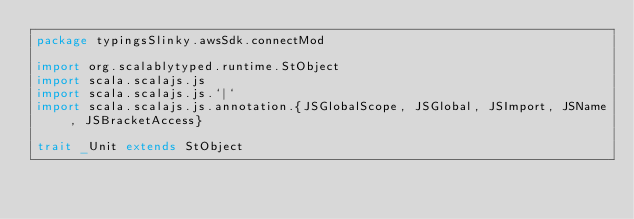<code> <loc_0><loc_0><loc_500><loc_500><_Scala_>package typingsSlinky.awsSdk.connectMod

import org.scalablytyped.runtime.StObject
import scala.scalajs.js
import scala.scalajs.js.`|`
import scala.scalajs.js.annotation.{JSGlobalScope, JSGlobal, JSImport, JSName, JSBracketAccess}

trait _Unit extends StObject
</code> 